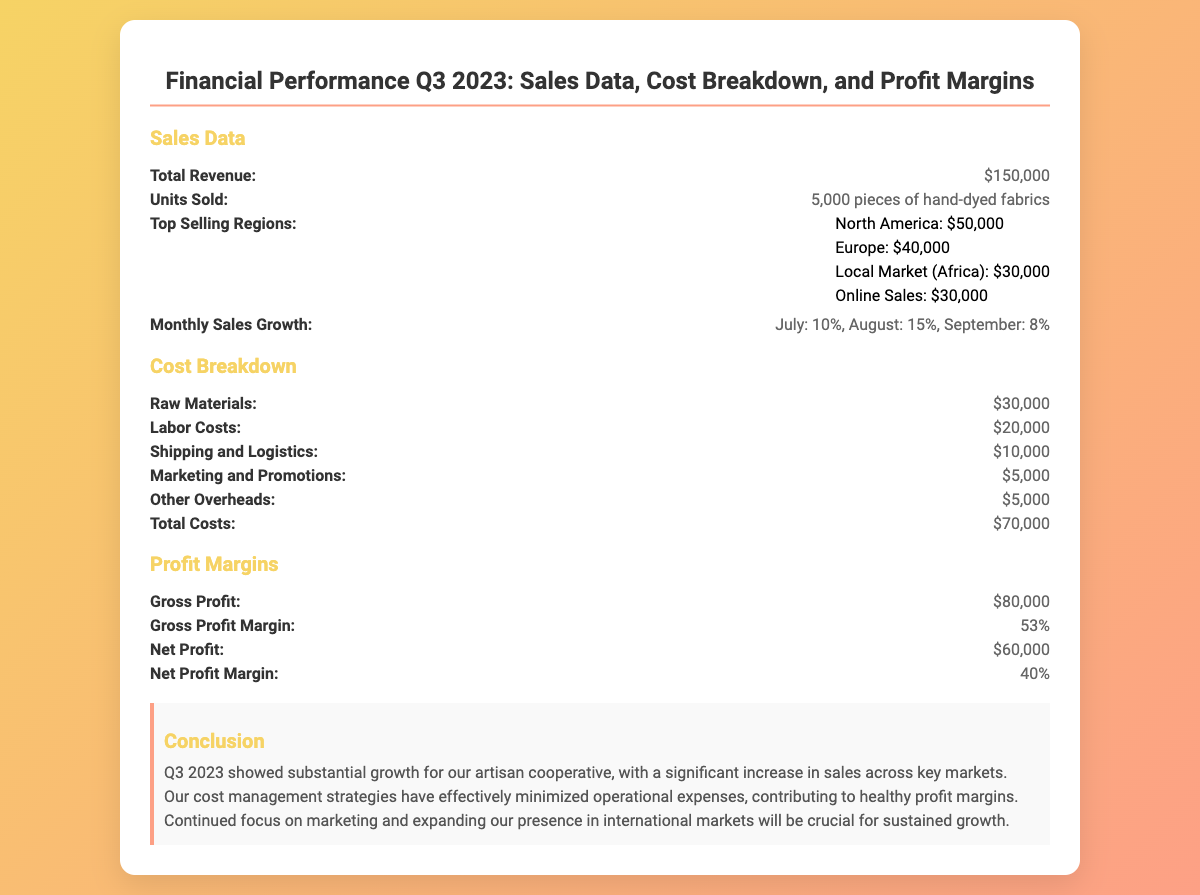What is the total revenue? The total revenue is the overall figure presented for Q3 2023, which is $150,000.
Answer: $150,000 How many units were sold? The document states the total number of pieces sold, which amounts to 5,000 pieces of hand-dyed fabrics.
Answer: 5,000 pieces What were the sales in North America? The specific revenue generated from the North American region is mentioned as $50,000.
Answer: $50,000 What is the total cost? The total costs are summarized in the document as $70,000.
Answer: $70,000 What is the gross profit? The gross profit is calculated and listed in the document as $80,000.
Answer: $80,000 What is the net profit margin? The document specifies the net profit margin as 40%.
Answer: 40% Which month had the highest sales growth? The document indicates that August had the highest sales growth at 15%.
Answer: August What are the top three selling regions by revenue? The top three selling regions are North America, Europe, and the Local Market (Africa), with respective revenues of $50,000, $40,000, and $30,000.
Answer: North America, Europe, Local Market (Africa) What cost accounted for the highest expenditure? The raw materials accounted for the highest expenditure at $30,000.
Answer: Raw Materials 